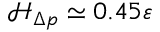<formula> <loc_0><loc_0><loc_500><loc_500>\mathcal { H } _ { \Delta p } \simeq 0 . 4 5 \varepsilon</formula> 